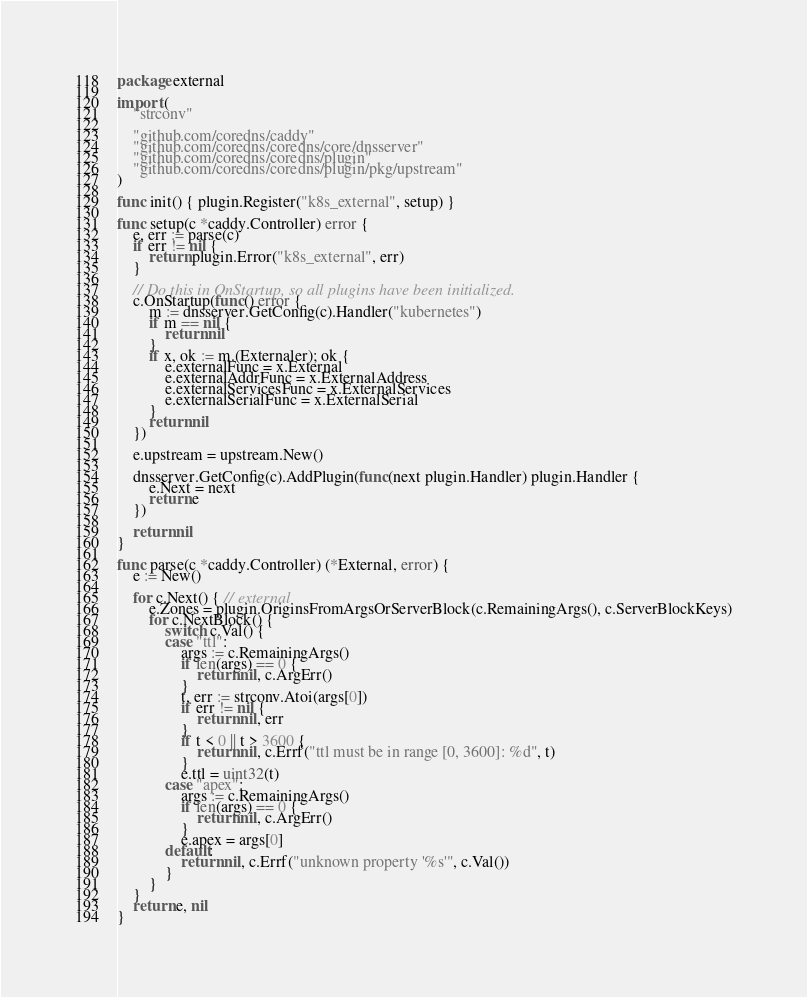<code> <loc_0><loc_0><loc_500><loc_500><_Go_>package external

import (
	"strconv"

	"github.com/coredns/caddy"
	"github.com/coredns/coredns/core/dnsserver"
	"github.com/coredns/coredns/plugin"
	"github.com/coredns/coredns/plugin/pkg/upstream"
)

func init() { plugin.Register("k8s_external", setup) }

func setup(c *caddy.Controller) error {
	e, err := parse(c)
	if err != nil {
		return plugin.Error("k8s_external", err)
	}

	// Do this in OnStartup, so all plugins have been initialized.
	c.OnStartup(func() error {
		m := dnsserver.GetConfig(c).Handler("kubernetes")
		if m == nil {
			return nil
		}
		if x, ok := m.(Externaler); ok {
			e.externalFunc = x.External
			e.externalAddrFunc = x.ExternalAddress
			e.externalServicesFunc = x.ExternalServices
			e.externalSerialFunc = x.ExternalSerial
		}
		return nil
	})

	e.upstream = upstream.New()

	dnsserver.GetConfig(c).AddPlugin(func(next plugin.Handler) plugin.Handler {
		e.Next = next
		return e
	})

	return nil
}

func parse(c *caddy.Controller) (*External, error) {
	e := New()

	for c.Next() { // external
		e.Zones = plugin.OriginsFromArgsOrServerBlock(c.RemainingArgs(), c.ServerBlockKeys)
		for c.NextBlock() {
			switch c.Val() {
			case "ttl":
				args := c.RemainingArgs()
				if len(args) == 0 {
					return nil, c.ArgErr()
				}
				t, err := strconv.Atoi(args[0])
				if err != nil {
					return nil, err
				}
				if t < 0 || t > 3600 {
					return nil, c.Errf("ttl must be in range [0, 3600]: %d", t)
				}
				e.ttl = uint32(t)
			case "apex":
				args := c.RemainingArgs()
				if len(args) == 0 {
					return nil, c.ArgErr()
				}
				e.apex = args[0]
			default:
				return nil, c.Errf("unknown property '%s'", c.Val())
			}
		}
	}
	return e, nil
}
</code> 